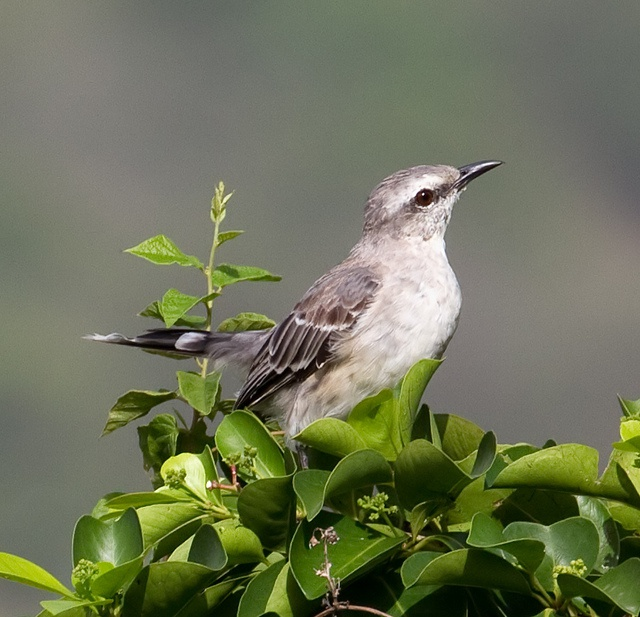Describe the objects in this image and their specific colors. I can see a bird in gray, lightgray, darkgray, and black tones in this image. 